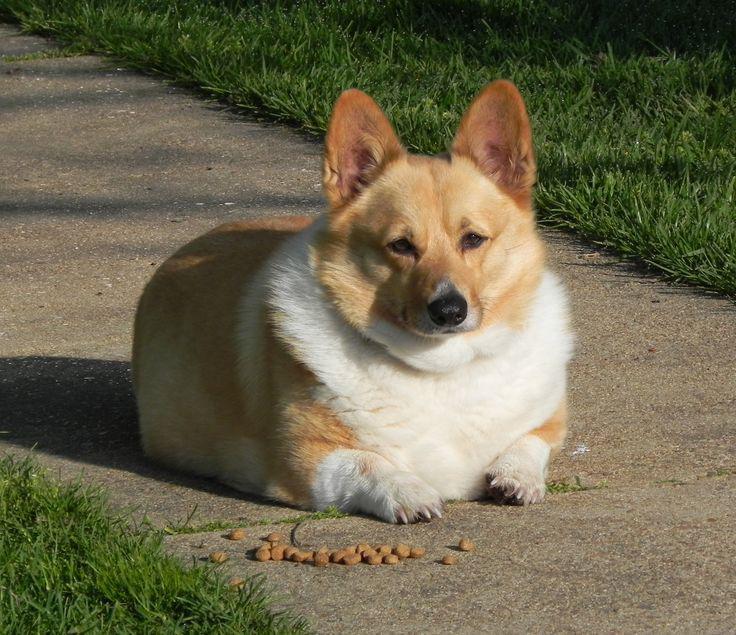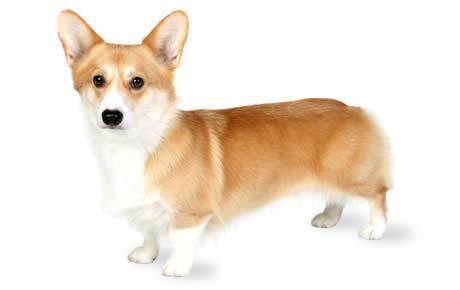The first image is the image on the left, the second image is the image on the right. Analyze the images presented: Is the assertion "At least one image contains only one dog, which is standing on all fours and has its mouth closed." valid? Answer yes or no. Yes. The first image is the image on the left, the second image is the image on the right. Given the left and right images, does the statement "One of the dogs is near grass, but not actually IN grass." hold true? Answer yes or no. Yes. 